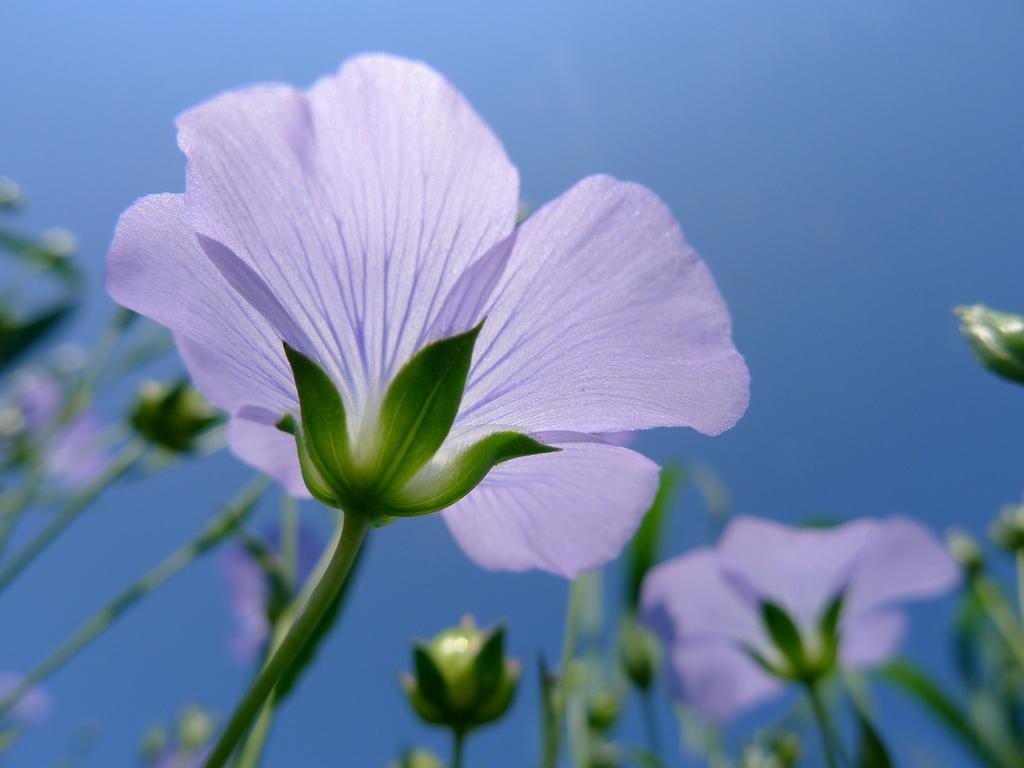How would you summarize this image in a sentence or two? In this picture we can see few flowers. 